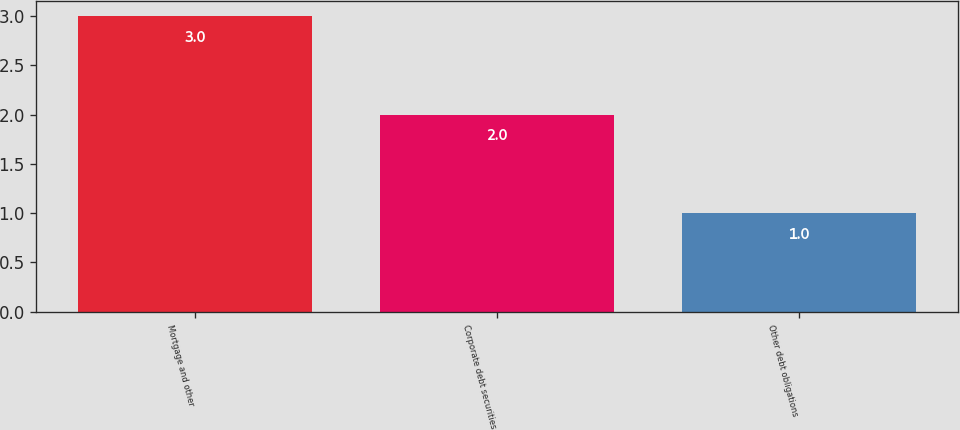<chart> <loc_0><loc_0><loc_500><loc_500><bar_chart><fcel>Mortgage and other<fcel>Corporate debt securities<fcel>Other debt obligations<nl><fcel>3<fcel>2<fcel>1<nl></chart> 